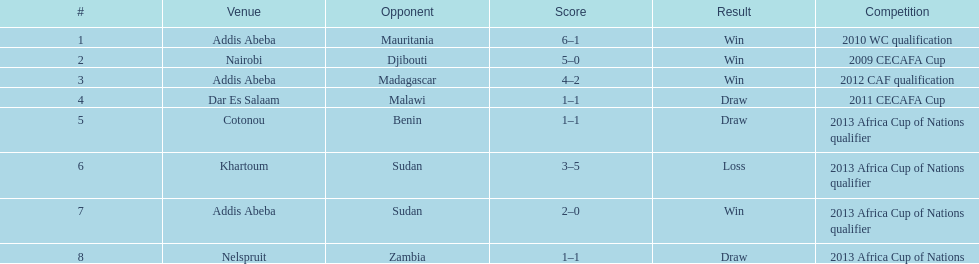What date gives was their only loss? 8 September 2012. 